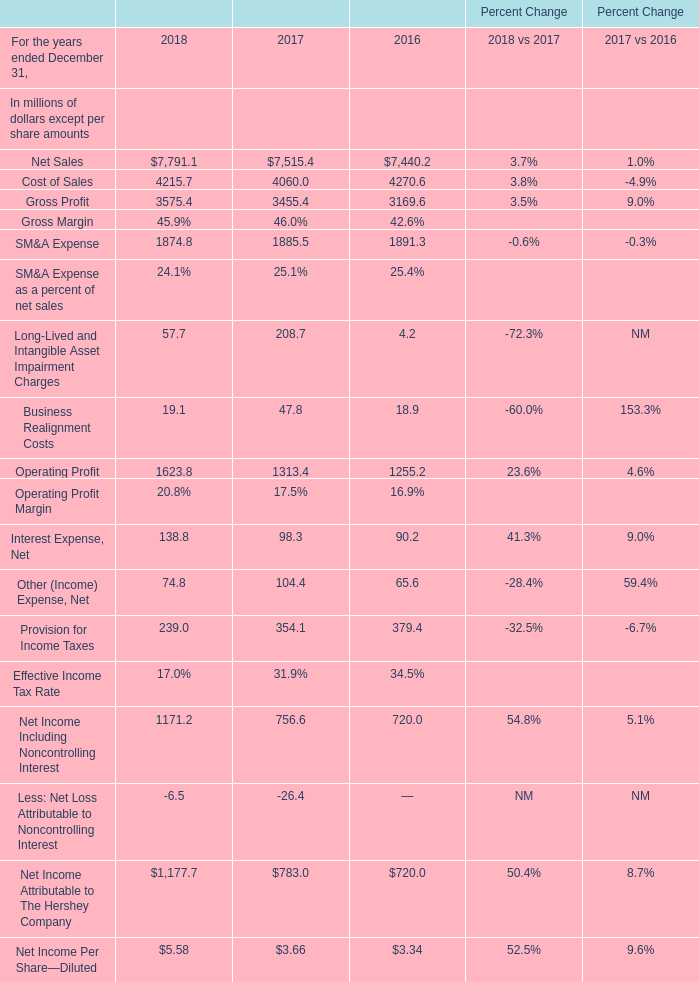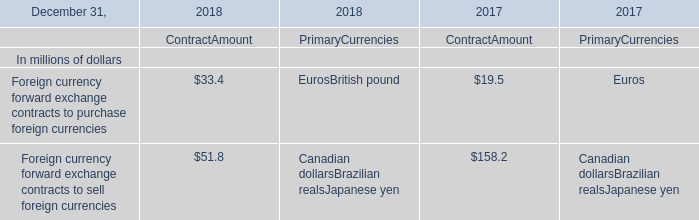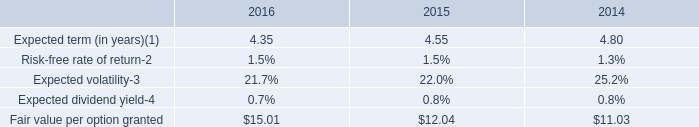What is the difference between 2018 and 2017 's Net Sales? (in million) 
Computations: (7791.1 - 7515.4)
Answer: 275.7. 